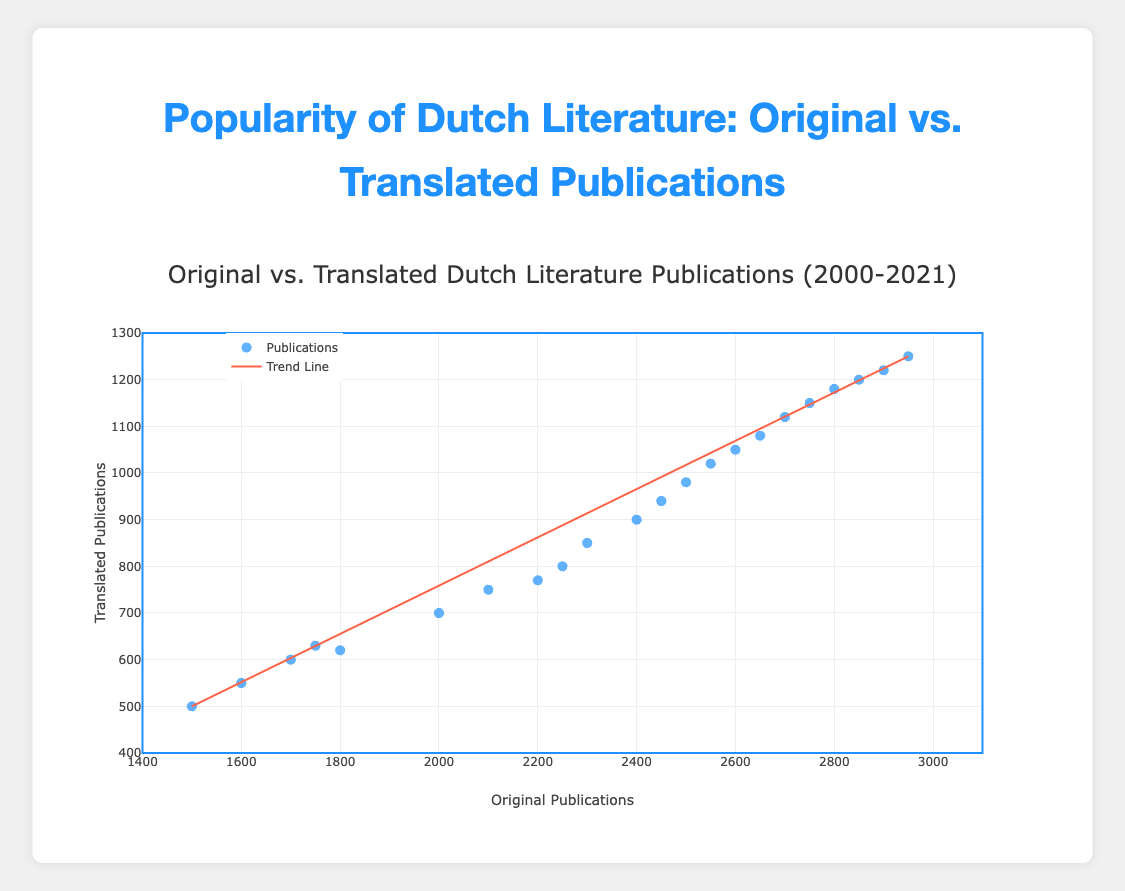What's the title of the figure? The title of the figure is present at the top and it reads "Original vs. Translated Dutch Literature Publications (2000-2021)".
Answer: Original vs. Translated Dutch Literature Publications (2000-2021) How do original publications compare to translated publications in 2005? For 2005, the data points for original and translated publications can be identified by hovering over or directly looking at the markers corresponding to the year 2005, which show original publications at 2000 and translated publications at 700.
Answer: Original: 2000, Translated: 700 What is the range of translated publications over the years shown in the plot? The y-axis represents translated publications with data points ranging from a minimum of 500 to a maximum of 1250, as observed from the scatter plot.
Answer: 500 to 1250 Which years had less than 800 translated publications? By examining the y-values and corresponding hover texts of the plot, the years with less than 800 translated publications are 2000-2007.
Answer: 2000 to 2007 What trend can be observed from the trend line in the plot? The trend line indicates a positive linear relationship between original and translated publications, meaning as the number of original publications increases, the number of translated publications also increases.
Answer: Positive linear relationship Between which years did the number of original publications first surpass 2000? By inspecting the x-values and corresponding hover texts, the number of original publications first surpasses 2000 in the year 2005.
Answer: 2005 How many data points are present in the scatter plot? Each marker in the scatter plot represents a data point, and counting them reveals that there are 22 data points.
Answer: 22 In which year did translated publications reach 1000 for the first time? By checking the hover texts for translated publications, 1000 translated publications were first reached in the year 2013.
Answer: 2013 Are there any years where translated publications decrease from the previous year? By observing the hover texts, it can be noted that translated publications consistently increase each year without any decrease.
Answer: No What is the approximate slope of the trend line? By choosing two points on the trend line, such as (1500, 500) and (2950, 1250), the slope can be calculated as (1250-500) / (2950-1500) which simplifies to approximately 0.517.
Answer: 0.517 